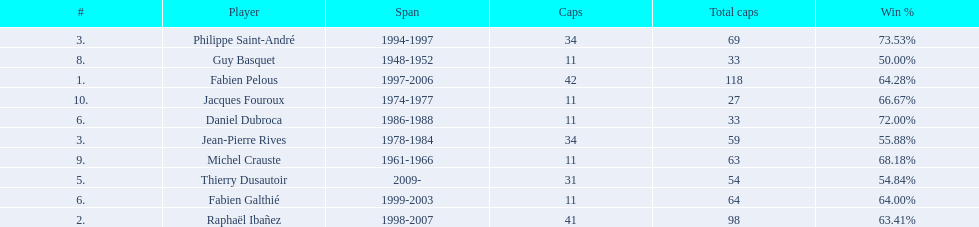Which player has the highest win percentage? Philippe Saint-André. 